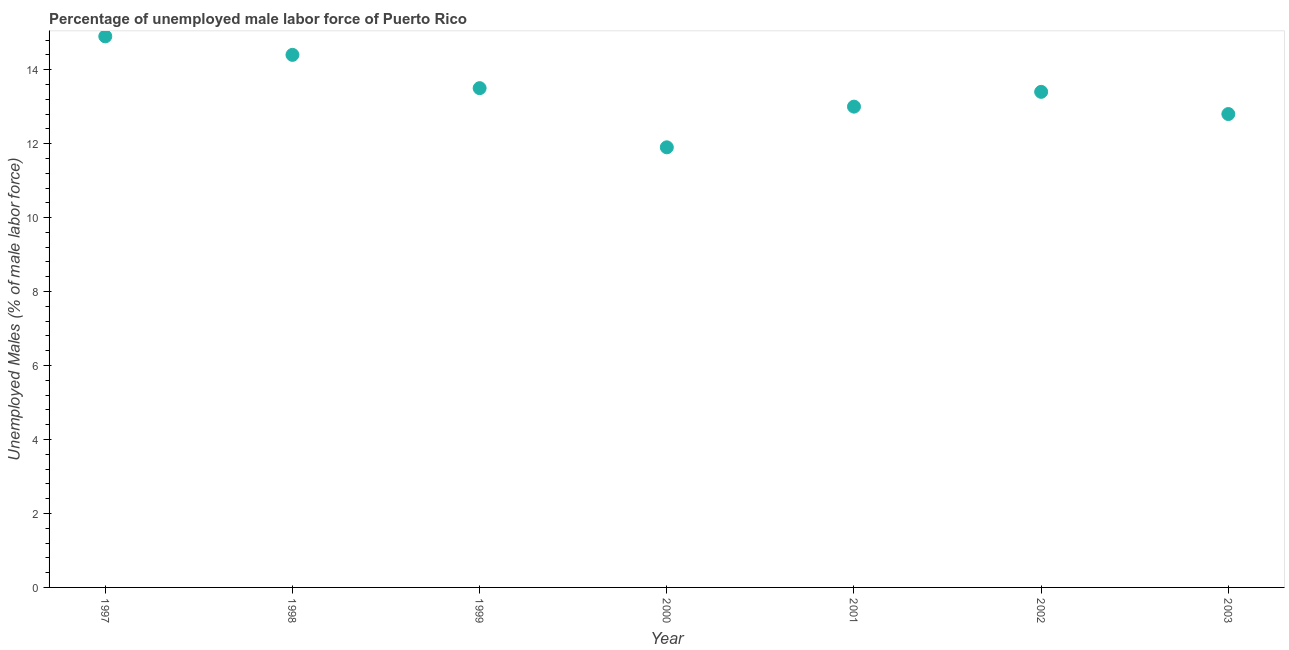What is the total unemployed male labour force in 1999?
Offer a very short reply. 13.5. Across all years, what is the maximum total unemployed male labour force?
Your answer should be compact. 14.9. Across all years, what is the minimum total unemployed male labour force?
Make the answer very short. 11.9. In which year was the total unemployed male labour force maximum?
Provide a short and direct response. 1997. In which year was the total unemployed male labour force minimum?
Keep it short and to the point. 2000. What is the sum of the total unemployed male labour force?
Keep it short and to the point. 93.9. What is the difference between the total unemployed male labour force in 1998 and 2003?
Offer a terse response. 1.6. What is the average total unemployed male labour force per year?
Make the answer very short. 13.41. What is the median total unemployed male labour force?
Offer a terse response. 13.4. What is the ratio of the total unemployed male labour force in 1997 to that in 2000?
Provide a succinct answer. 1.25. Is the total unemployed male labour force in 1999 less than that in 2003?
Make the answer very short. No. What is the difference between the highest and the second highest total unemployed male labour force?
Provide a short and direct response. 0.5. What is the difference between the highest and the lowest total unemployed male labour force?
Your answer should be very brief. 3. In how many years, is the total unemployed male labour force greater than the average total unemployed male labour force taken over all years?
Offer a terse response. 3. How many years are there in the graph?
Your answer should be compact. 7. What is the difference between two consecutive major ticks on the Y-axis?
Provide a succinct answer. 2. What is the title of the graph?
Offer a terse response. Percentage of unemployed male labor force of Puerto Rico. What is the label or title of the Y-axis?
Ensure brevity in your answer.  Unemployed Males (% of male labor force). What is the Unemployed Males (% of male labor force) in 1997?
Your response must be concise. 14.9. What is the Unemployed Males (% of male labor force) in 1998?
Your answer should be very brief. 14.4. What is the Unemployed Males (% of male labor force) in 1999?
Offer a very short reply. 13.5. What is the Unemployed Males (% of male labor force) in 2000?
Keep it short and to the point. 11.9. What is the Unemployed Males (% of male labor force) in 2002?
Offer a very short reply. 13.4. What is the Unemployed Males (% of male labor force) in 2003?
Keep it short and to the point. 12.8. What is the difference between the Unemployed Males (% of male labor force) in 1997 and 1998?
Your answer should be compact. 0.5. What is the difference between the Unemployed Males (% of male labor force) in 1997 and 1999?
Offer a very short reply. 1.4. What is the difference between the Unemployed Males (% of male labor force) in 1997 and 2000?
Provide a succinct answer. 3. What is the difference between the Unemployed Males (% of male labor force) in 1998 and 1999?
Your response must be concise. 0.9. What is the difference between the Unemployed Males (% of male labor force) in 1998 and 2000?
Your response must be concise. 2.5. What is the difference between the Unemployed Males (% of male labor force) in 1998 and 2001?
Ensure brevity in your answer.  1.4. What is the difference between the Unemployed Males (% of male labor force) in 1998 and 2002?
Your answer should be very brief. 1. What is the difference between the Unemployed Males (% of male labor force) in 1999 and 2000?
Offer a very short reply. 1.6. What is the difference between the Unemployed Males (% of male labor force) in 1999 and 2001?
Offer a terse response. 0.5. What is the difference between the Unemployed Males (% of male labor force) in 2000 and 2002?
Provide a short and direct response. -1.5. What is the difference between the Unemployed Males (% of male labor force) in 2001 and 2002?
Ensure brevity in your answer.  -0.4. What is the difference between the Unemployed Males (% of male labor force) in 2001 and 2003?
Offer a terse response. 0.2. What is the ratio of the Unemployed Males (% of male labor force) in 1997 to that in 1998?
Give a very brief answer. 1.03. What is the ratio of the Unemployed Males (% of male labor force) in 1997 to that in 1999?
Offer a very short reply. 1.1. What is the ratio of the Unemployed Males (% of male labor force) in 1997 to that in 2000?
Keep it short and to the point. 1.25. What is the ratio of the Unemployed Males (% of male labor force) in 1997 to that in 2001?
Offer a terse response. 1.15. What is the ratio of the Unemployed Males (% of male labor force) in 1997 to that in 2002?
Provide a succinct answer. 1.11. What is the ratio of the Unemployed Males (% of male labor force) in 1997 to that in 2003?
Make the answer very short. 1.16. What is the ratio of the Unemployed Males (% of male labor force) in 1998 to that in 1999?
Make the answer very short. 1.07. What is the ratio of the Unemployed Males (% of male labor force) in 1998 to that in 2000?
Make the answer very short. 1.21. What is the ratio of the Unemployed Males (% of male labor force) in 1998 to that in 2001?
Your answer should be very brief. 1.11. What is the ratio of the Unemployed Males (% of male labor force) in 1998 to that in 2002?
Your answer should be very brief. 1.07. What is the ratio of the Unemployed Males (% of male labor force) in 1999 to that in 2000?
Your response must be concise. 1.13. What is the ratio of the Unemployed Males (% of male labor force) in 1999 to that in 2001?
Give a very brief answer. 1.04. What is the ratio of the Unemployed Males (% of male labor force) in 1999 to that in 2003?
Make the answer very short. 1.05. What is the ratio of the Unemployed Males (% of male labor force) in 2000 to that in 2001?
Keep it short and to the point. 0.92. What is the ratio of the Unemployed Males (% of male labor force) in 2000 to that in 2002?
Your answer should be compact. 0.89. What is the ratio of the Unemployed Males (% of male labor force) in 2000 to that in 2003?
Give a very brief answer. 0.93. What is the ratio of the Unemployed Males (% of male labor force) in 2002 to that in 2003?
Offer a very short reply. 1.05. 